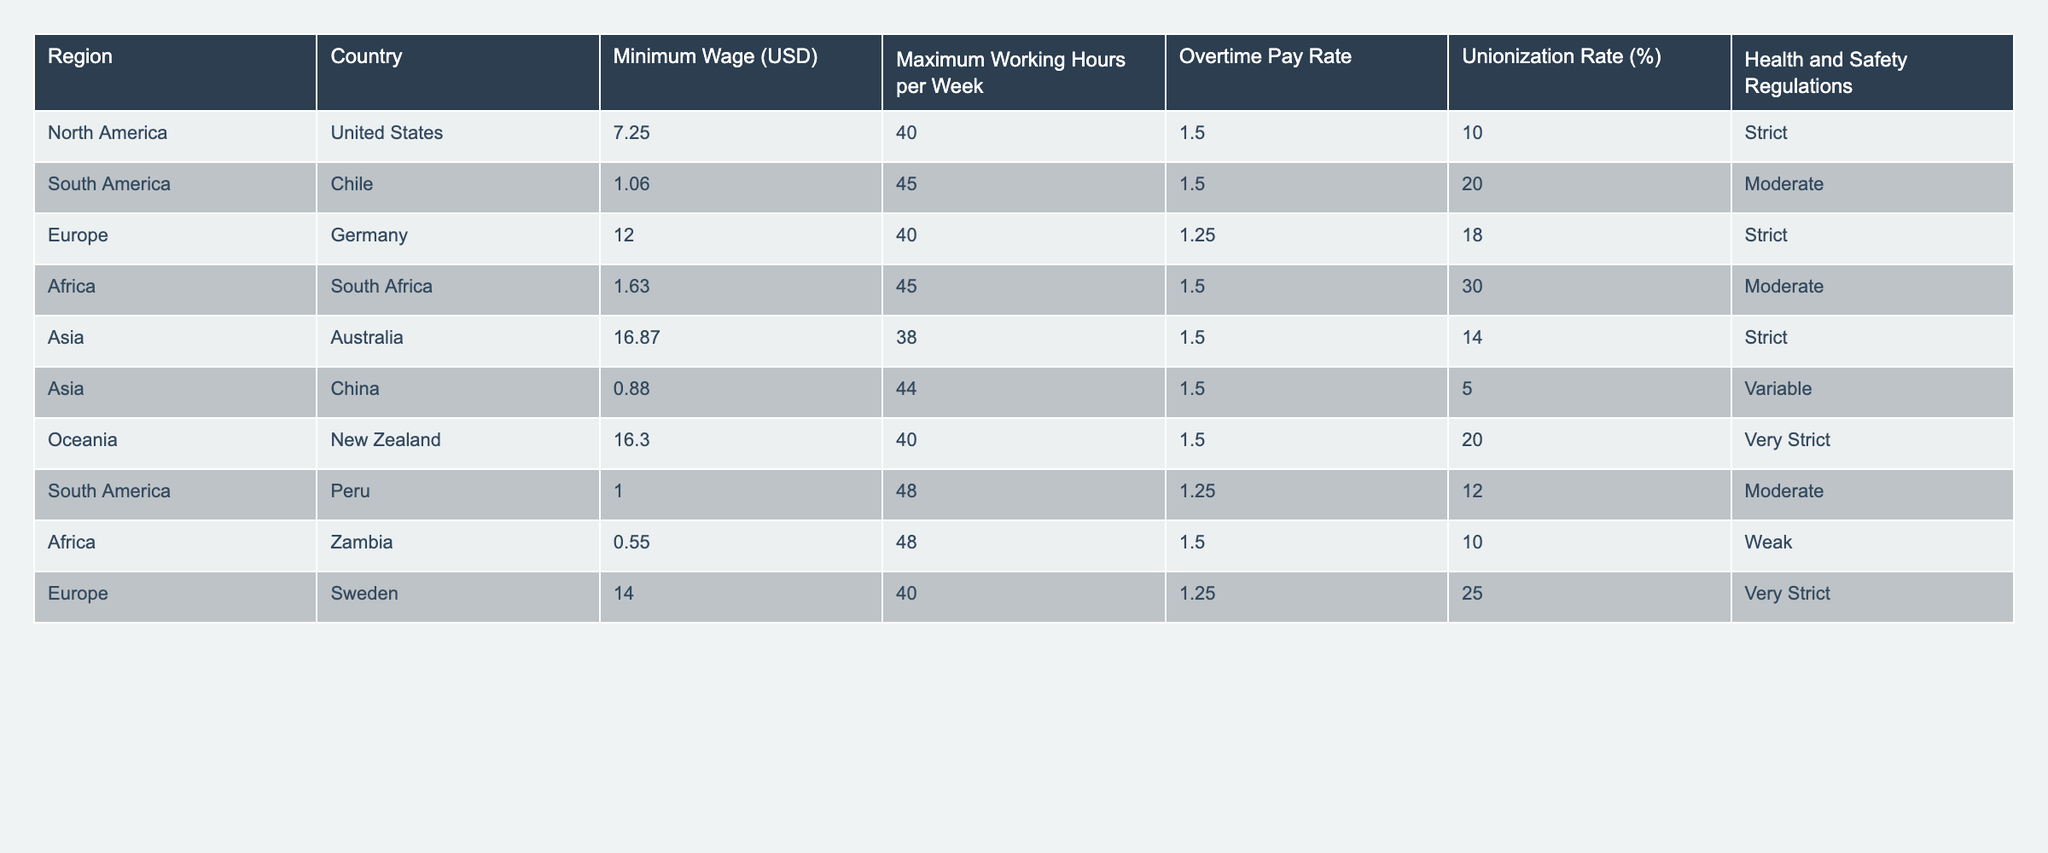What is the minimum wage in Australia? The table lists Australia with a minimum wage of 16.87 USD.
Answer: 16.87 USD Which region has the highest unionization rate? By checking the values in the table, South Africa has the highest unionization rate at 30%.
Answer: 30% How many regions have maximum working hours over 40 per week? The regions with maximum working hours over 40 are South America (Chile, Peru) and Africa (South Africa, Zambia), which totals 4 regions.
Answer: 4 regions Is the overtime pay rate the same across all regions? The table shows varying overtime pay rates, indicating they are not the same.
Answer: No What is the average minimum wage across all regions? To find the average, sum the minimum wages: (7.25 + 1.06 + 12.00 + 1.63 + 16.87 + 0.88 + 16.30 + 1.00 + 0.55 + 14.00) = 71.59. There are 10 data points, so the average is 71.59 / 10 = 7.16 USD.
Answer: 7.16 USD Which country has the strictest health and safety regulations? By reviewing the health and safety regulations column, New Zealand has the label “Very Strict.”
Answer: New Zealand Is there a country in Asia with a minimum wage lower than USD 1? China has a minimum wage of 0.88 USD, indicating it is below 1 USD.
Answer: Yes What is the difference in maximum working hours between Zambia and Germany? Zambia has maximum working hours of 48, while Germany has 40. The difference is 48 - 40 = 8 hours.
Answer: 8 hours Which region has the lowest minimum wage and what is it? The table indicates that Zambia has the lowest minimum wage at 0.55 USD.
Answer: 0.55 USD How does the unionization rate in South America compare with that in Africa? South America has unionization rates of 20% (Chile) and 12% (Peru), averaging 16%. Africa has rates of 30% (South Africa) and 10% (Zambia), averaging 20%. Africa has a higher average unionization rate.
Answer: Africa is higher 